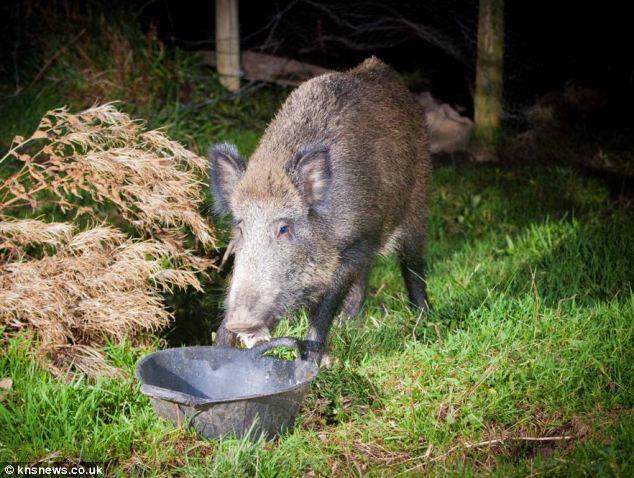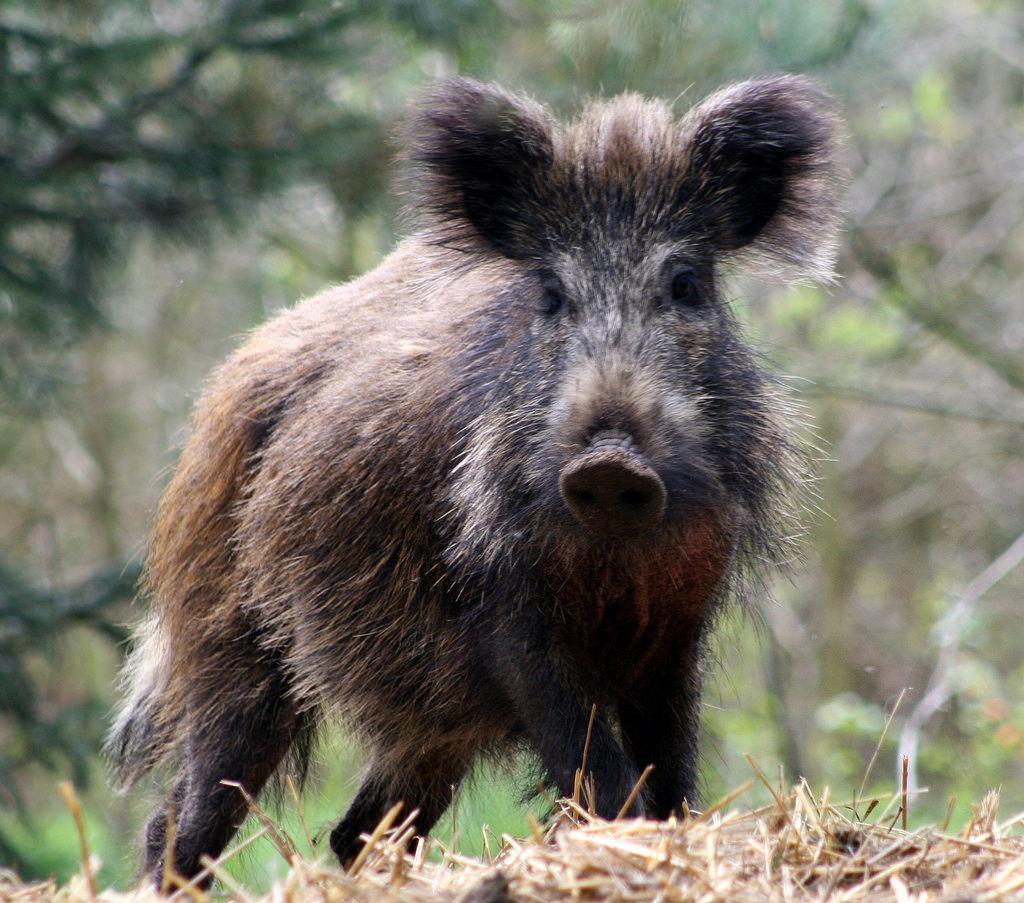The first image is the image on the left, the second image is the image on the right. Analyze the images presented: Is the assertion "One image shows a boar standing in the mud." valid? Answer yes or no. No. 